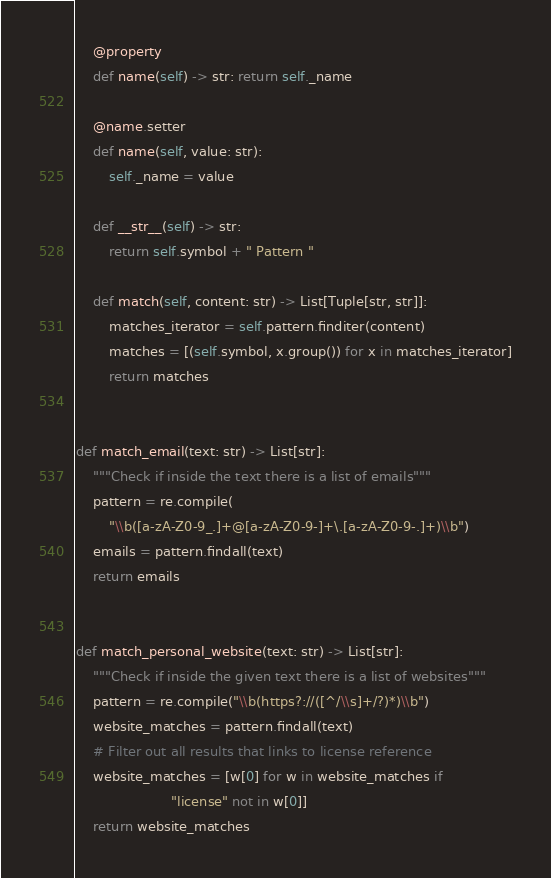<code> <loc_0><loc_0><loc_500><loc_500><_Python_>
    @property
    def name(self) -> str: return self._name

    @name.setter
    def name(self, value: str):
        self._name = value

    def __str__(self) -> str:
        return self.symbol + " Pattern "

    def match(self, content: str) -> List[Tuple[str, str]]:
        matches_iterator = self.pattern.finditer(content)
        matches = [(self.symbol, x.group()) for x in matches_iterator]
        return matches


def match_email(text: str) -> List[str]:
    """Check if inside the text there is a list of emails"""
    pattern = re.compile(
        "\\b([a-zA-Z0-9_.]+@[a-zA-Z0-9-]+\.[a-zA-Z0-9-.]+)\\b")
    emails = pattern.findall(text)
    return emails


def match_personal_website(text: str) -> List[str]:
    """Check if inside the given text there is a list of websites"""
    pattern = re.compile("\\b(https?://([^/\\s]+/?)*)\\b")
    website_matches = pattern.findall(text)
    # Filter out all results that links to license reference
    website_matches = [w[0] for w in website_matches if
                       "license" not in w[0]]
    return website_matches
</code> 